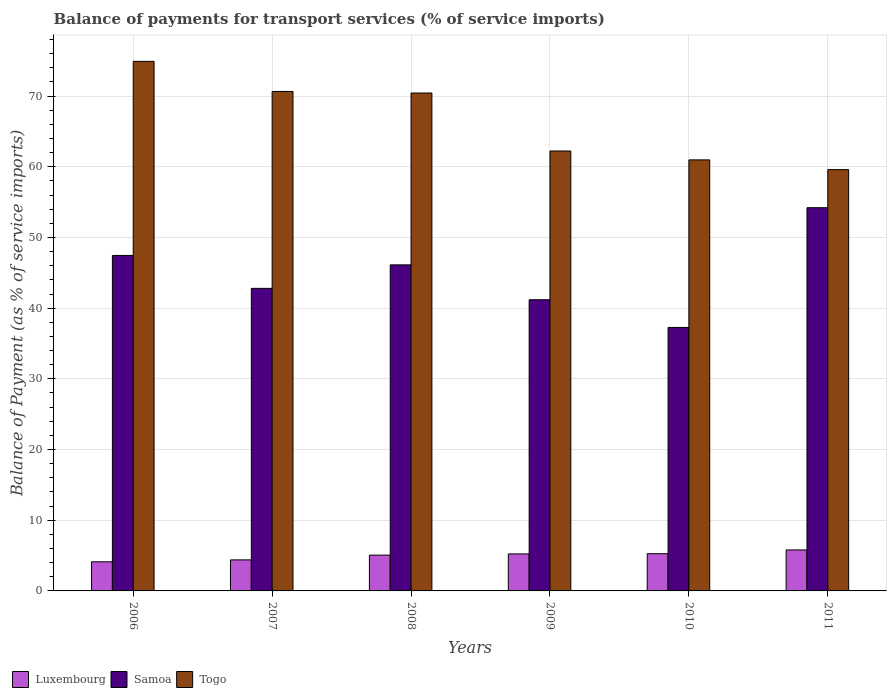How many groups of bars are there?
Provide a succinct answer. 6. Are the number of bars per tick equal to the number of legend labels?
Your answer should be very brief. Yes. How many bars are there on the 5th tick from the left?
Offer a very short reply. 3. What is the balance of payments for transport services in Luxembourg in 2008?
Keep it short and to the point. 5.07. Across all years, what is the maximum balance of payments for transport services in Samoa?
Ensure brevity in your answer.  54.21. Across all years, what is the minimum balance of payments for transport services in Luxembourg?
Give a very brief answer. 4.12. In which year was the balance of payments for transport services in Togo maximum?
Provide a succinct answer. 2006. What is the total balance of payments for transport services in Togo in the graph?
Offer a terse response. 398.79. What is the difference between the balance of payments for transport services in Luxembourg in 2007 and that in 2011?
Your answer should be compact. -1.41. What is the difference between the balance of payments for transport services in Samoa in 2009 and the balance of payments for transport services in Togo in 2006?
Your answer should be compact. -33.72. What is the average balance of payments for transport services in Togo per year?
Provide a succinct answer. 66.46. In the year 2011, what is the difference between the balance of payments for transport services in Samoa and balance of payments for transport services in Togo?
Provide a succinct answer. -5.38. In how many years, is the balance of payments for transport services in Samoa greater than 64 %?
Give a very brief answer. 0. What is the ratio of the balance of payments for transport services in Luxembourg in 2008 to that in 2010?
Offer a very short reply. 0.96. Is the balance of payments for transport services in Luxembourg in 2006 less than that in 2007?
Provide a short and direct response. Yes. Is the difference between the balance of payments for transport services in Samoa in 2008 and 2010 greater than the difference between the balance of payments for transport services in Togo in 2008 and 2010?
Give a very brief answer. No. What is the difference between the highest and the second highest balance of payments for transport services in Luxembourg?
Offer a very short reply. 0.53. What is the difference between the highest and the lowest balance of payments for transport services in Samoa?
Offer a very short reply. 16.94. What does the 3rd bar from the left in 2010 represents?
Offer a very short reply. Togo. What does the 1st bar from the right in 2011 represents?
Ensure brevity in your answer.  Togo. Is it the case that in every year, the sum of the balance of payments for transport services in Luxembourg and balance of payments for transport services in Togo is greater than the balance of payments for transport services in Samoa?
Ensure brevity in your answer.  Yes. Are all the bars in the graph horizontal?
Your response must be concise. No. What is the difference between two consecutive major ticks on the Y-axis?
Offer a terse response. 10. How many legend labels are there?
Your answer should be very brief. 3. How are the legend labels stacked?
Keep it short and to the point. Horizontal. What is the title of the graph?
Your answer should be compact. Balance of payments for transport services (% of service imports). Does "Trinidad and Tobago" appear as one of the legend labels in the graph?
Your answer should be very brief. No. What is the label or title of the X-axis?
Provide a short and direct response. Years. What is the label or title of the Y-axis?
Provide a short and direct response. Balance of Payment (as % of service imports). What is the Balance of Payment (as % of service imports) of Luxembourg in 2006?
Your response must be concise. 4.12. What is the Balance of Payment (as % of service imports) of Samoa in 2006?
Offer a very short reply. 47.45. What is the Balance of Payment (as % of service imports) in Togo in 2006?
Provide a short and direct response. 74.91. What is the Balance of Payment (as % of service imports) in Luxembourg in 2007?
Your answer should be very brief. 4.39. What is the Balance of Payment (as % of service imports) of Samoa in 2007?
Keep it short and to the point. 42.8. What is the Balance of Payment (as % of service imports) of Togo in 2007?
Your answer should be compact. 70.65. What is the Balance of Payment (as % of service imports) in Luxembourg in 2008?
Provide a short and direct response. 5.07. What is the Balance of Payment (as % of service imports) in Samoa in 2008?
Provide a succinct answer. 46.12. What is the Balance of Payment (as % of service imports) in Togo in 2008?
Make the answer very short. 70.43. What is the Balance of Payment (as % of service imports) in Luxembourg in 2009?
Your answer should be compact. 5.23. What is the Balance of Payment (as % of service imports) in Samoa in 2009?
Offer a terse response. 41.19. What is the Balance of Payment (as % of service imports) in Togo in 2009?
Make the answer very short. 62.23. What is the Balance of Payment (as % of service imports) in Luxembourg in 2010?
Your answer should be compact. 5.27. What is the Balance of Payment (as % of service imports) of Samoa in 2010?
Give a very brief answer. 37.27. What is the Balance of Payment (as % of service imports) of Togo in 2010?
Offer a terse response. 60.97. What is the Balance of Payment (as % of service imports) of Luxembourg in 2011?
Offer a terse response. 5.8. What is the Balance of Payment (as % of service imports) of Samoa in 2011?
Keep it short and to the point. 54.21. What is the Balance of Payment (as % of service imports) of Togo in 2011?
Offer a very short reply. 59.59. Across all years, what is the maximum Balance of Payment (as % of service imports) of Luxembourg?
Offer a very short reply. 5.8. Across all years, what is the maximum Balance of Payment (as % of service imports) in Samoa?
Make the answer very short. 54.21. Across all years, what is the maximum Balance of Payment (as % of service imports) of Togo?
Your answer should be very brief. 74.91. Across all years, what is the minimum Balance of Payment (as % of service imports) of Luxembourg?
Offer a very short reply. 4.12. Across all years, what is the minimum Balance of Payment (as % of service imports) in Samoa?
Keep it short and to the point. 37.27. Across all years, what is the minimum Balance of Payment (as % of service imports) in Togo?
Keep it short and to the point. 59.59. What is the total Balance of Payment (as % of service imports) of Luxembourg in the graph?
Provide a short and direct response. 29.88. What is the total Balance of Payment (as % of service imports) in Samoa in the graph?
Your response must be concise. 269.04. What is the total Balance of Payment (as % of service imports) in Togo in the graph?
Your answer should be compact. 398.79. What is the difference between the Balance of Payment (as % of service imports) of Luxembourg in 2006 and that in 2007?
Provide a succinct answer. -0.27. What is the difference between the Balance of Payment (as % of service imports) of Samoa in 2006 and that in 2007?
Your answer should be compact. 4.66. What is the difference between the Balance of Payment (as % of service imports) of Togo in 2006 and that in 2007?
Provide a succinct answer. 4.26. What is the difference between the Balance of Payment (as % of service imports) in Luxembourg in 2006 and that in 2008?
Ensure brevity in your answer.  -0.94. What is the difference between the Balance of Payment (as % of service imports) of Samoa in 2006 and that in 2008?
Offer a very short reply. 1.33. What is the difference between the Balance of Payment (as % of service imports) in Togo in 2006 and that in 2008?
Your answer should be very brief. 4.48. What is the difference between the Balance of Payment (as % of service imports) of Luxembourg in 2006 and that in 2009?
Your answer should be compact. -1.11. What is the difference between the Balance of Payment (as % of service imports) of Samoa in 2006 and that in 2009?
Offer a very short reply. 6.27. What is the difference between the Balance of Payment (as % of service imports) in Togo in 2006 and that in 2009?
Offer a terse response. 12.68. What is the difference between the Balance of Payment (as % of service imports) of Luxembourg in 2006 and that in 2010?
Give a very brief answer. -1.14. What is the difference between the Balance of Payment (as % of service imports) in Samoa in 2006 and that in 2010?
Your answer should be very brief. 10.18. What is the difference between the Balance of Payment (as % of service imports) in Togo in 2006 and that in 2010?
Keep it short and to the point. 13.94. What is the difference between the Balance of Payment (as % of service imports) of Luxembourg in 2006 and that in 2011?
Your answer should be very brief. -1.68. What is the difference between the Balance of Payment (as % of service imports) in Samoa in 2006 and that in 2011?
Offer a terse response. -6.76. What is the difference between the Balance of Payment (as % of service imports) of Togo in 2006 and that in 2011?
Make the answer very short. 15.32. What is the difference between the Balance of Payment (as % of service imports) in Luxembourg in 2007 and that in 2008?
Provide a short and direct response. -0.67. What is the difference between the Balance of Payment (as % of service imports) of Samoa in 2007 and that in 2008?
Your response must be concise. -3.33. What is the difference between the Balance of Payment (as % of service imports) in Togo in 2007 and that in 2008?
Offer a very short reply. 0.22. What is the difference between the Balance of Payment (as % of service imports) of Luxembourg in 2007 and that in 2009?
Keep it short and to the point. -0.84. What is the difference between the Balance of Payment (as % of service imports) in Samoa in 2007 and that in 2009?
Provide a succinct answer. 1.61. What is the difference between the Balance of Payment (as % of service imports) in Togo in 2007 and that in 2009?
Offer a terse response. 8.42. What is the difference between the Balance of Payment (as % of service imports) of Luxembourg in 2007 and that in 2010?
Ensure brevity in your answer.  -0.87. What is the difference between the Balance of Payment (as % of service imports) of Samoa in 2007 and that in 2010?
Offer a very short reply. 5.53. What is the difference between the Balance of Payment (as % of service imports) in Togo in 2007 and that in 2010?
Your answer should be very brief. 9.68. What is the difference between the Balance of Payment (as % of service imports) in Luxembourg in 2007 and that in 2011?
Keep it short and to the point. -1.41. What is the difference between the Balance of Payment (as % of service imports) in Samoa in 2007 and that in 2011?
Provide a short and direct response. -11.41. What is the difference between the Balance of Payment (as % of service imports) of Togo in 2007 and that in 2011?
Provide a short and direct response. 11.06. What is the difference between the Balance of Payment (as % of service imports) in Luxembourg in 2008 and that in 2009?
Provide a short and direct response. -0.17. What is the difference between the Balance of Payment (as % of service imports) of Samoa in 2008 and that in 2009?
Your response must be concise. 4.93. What is the difference between the Balance of Payment (as % of service imports) of Togo in 2008 and that in 2009?
Provide a short and direct response. 8.2. What is the difference between the Balance of Payment (as % of service imports) of Luxembourg in 2008 and that in 2010?
Your answer should be very brief. -0.2. What is the difference between the Balance of Payment (as % of service imports) of Samoa in 2008 and that in 2010?
Provide a short and direct response. 8.85. What is the difference between the Balance of Payment (as % of service imports) in Togo in 2008 and that in 2010?
Make the answer very short. 9.46. What is the difference between the Balance of Payment (as % of service imports) in Luxembourg in 2008 and that in 2011?
Your answer should be compact. -0.73. What is the difference between the Balance of Payment (as % of service imports) of Samoa in 2008 and that in 2011?
Give a very brief answer. -8.09. What is the difference between the Balance of Payment (as % of service imports) in Togo in 2008 and that in 2011?
Keep it short and to the point. 10.84. What is the difference between the Balance of Payment (as % of service imports) of Luxembourg in 2009 and that in 2010?
Give a very brief answer. -0.03. What is the difference between the Balance of Payment (as % of service imports) in Samoa in 2009 and that in 2010?
Offer a very short reply. 3.92. What is the difference between the Balance of Payment (as % of service imports) in Togo in 2009 and that in 2010?
Ensure brevity in your answer.  1.26. What is the difference between the Balance of Payment (as % of service imports) of Luxembourg in 2009 and that in 2011?
Provide a short and direct response. -0.56. What is the difference between the Balance of Payment (as % of service imports) in Samoa in 2009 and that in 2011?
Keep it short and to the point. -13.02. What is the difference between the Balance of Payment (as % of service imports) in Togo in 2009 and that in 2011?
Offer a very short reply. 2.64. What is the difference between the Balance of Payment (as % of service imports) of Luxembourg in 2010 and that in 2011?
Give a very brief answer. -0.53. What is the difference between the Balance of Payment (as % of service imports) in Samoa in 2010 and that in 2011?
Offer a terse response. -16.94. What is the difference between the Balance of Payment (as % of service imports) in Togo in 2010 and that in 2011?
Your answer should be compact. 1.38. What is the difference between the Balance of Payment (as % of service imports) in Luxembourg in 2006 and the Balance of Payment (as % of service imports) in Samoa in 2007?
Offer a terse response. -38.67. What is the difference between the Balance of Payment (as % of service imports) in Luxembourg in 2006 and the Balance of Payment (as % of service imports) in Togo in 2007?
Provide a succinct answer. -66.53. What is the difference between the Balance of Payment (as % of service imports) of Samoa in 2006 and the Balance of Payment (as % of service imports) of Togo in 2007?
Make the answer very short. -23.2. What is the difference between the Balance of Payment (as % of service imports) of Luxembourg in 2006 and the Balance of Payment (as % of service imports) of Samoa in 2008?
Your response must be concise. -42. What is the difference between the Balance of Payment (as % of service imports) of Luxembourg in 2006 and the Balance of Payment (as % of service imports) of Togo in 2008?
Give a very brief answer. -66.31. What is the difference between the Balance of Payment (as % of service imports) in Samoa in 2006 and the Balance of Payment (as % of service imports) in Togo in 2008?
Make the answer very short. -22.98. What is the difference between the Balance of Payment (as % of service imports) in Luxembourg in 2006 and the Balance of Payment (as % of service imports) in Samoa in 2009?
Provide a succinct answer. -37.07. What is the difference between the Balance of Payment (as % of service imports) of Luxembourg in 2006 and the Balance of Payment (as % of service imports) of Togo in 2009?
Provide a short and direct response. -58.11. What is the difference between the Balance of Payment (as % of service imports) of Samoa in 2006 and the Balance of Payment (as % of service imports) of Togo in 2009?
Give a very brief answer. -14.77. What is the difference between the Balance of Payment (as % of service imports) of Luxembourg in 2006 and the Balance of Payment (as % of service imports) of Samoa in 2010?
Provide a short and direct response. -33.15. What is the difference between the Balance of Payment (as % of service imports) of Luxembourg in 2006 and the Balance of Payment (as % of service imports) of Togo in 2010?
Make the answer very short. -56.85. What is the difference between the Balance of Payment (as % of service imports) of Samoa in 2006 and the Balance of Payment (as % of service imports) of Togo in 2010?
Provide a short and direct response. -13.52. What is the difference between the Balance of Payment (as % of service imports) in Luxembourg in 2006 and the Balance of Payment (as % of service imports) in Samoa in 2011?
Your answer should be compact. -50.09. What is the difference between the Balance of Payment (as % of service imports) in Luxembourg in 2006 and the Balance of Payment (as % of service imports) in Togo in 2011?
Ensure brevity in your answer.  -55.47. What is the difference between the Balance of Payment (as % of service imports) in Samoa in 2006 and the Balance of Payment (as % of service imports) in Togo in 2011?
Offer a terse response. -12.14. What is the difference between the Balance of Payment (as % of service imports) in Luxembourg in 2007 and the Balance of Payment (as % of service imports) in Samoa in 2008?
Your answer should be very brief. -41.73. What is the difference between the Balance of Payment (as % of service imports) in Luxembourg in 2007 and the Balance of Payment (as % of service imports) in Togo in 2008?
Offer a very short reply. -66.04. What is the difference between the Balance of Payment (as % of service imports) in Samoa in 2007 and the Balance of Payment (as % of service imports) in Togo in 2008?
Keep it short and to the point. -27.63. What is the difference between the Balance of Payment (as % of service imports) of Luxembourg in 2007 and the Balance of Payment (as % of service imports) of Samoa in 2009?
Your response must be concise. -36.8. What is the difference between the Balance of Payment (as % of service imports) of Luxembourg in 2007 and the Balance of Payment (as % of service imports) of Togo in 2009?
Give a very brief answer. -57.84. What is the difference between the Balance of Payment (as % of service imports) of Samoa in 2007 and the Balance of Payment (as % of service imports) of Togo in 2009?
Make the answer very short. -19.43. What is the difference between the Balance of Payment (as % of service imports) in Luxembourg in 2007 and the Balance of Payment (as % of service imports) in Samoa in 2010?
Give a very brief answer. -32.88. What is the difference between the Balance of Payment (as % of service imports) of Luxembourg in 2007 and the Balance of Payment (as % of service imports) of Togo in 2010?
Ensure brevity in your answer.  -56.58. What is the difference between the Balance of Payment (as % of service imports) of Samoa in 2007 and the Balance of Payment (as % of service imports) of Togo in 2010?
Make the answer very short. -18.18. What is the difference between the Balance of Payment (as % of service imports) in Luxembourg in 2007 and the Balance of Payment (as % of service imports) in Samoa in 2011?
Offer a terse response. -49.82. What is the difference between the Balance of Payment (as % of service imports) of Luxembourg in 2007 and the Balance of Payment (as % of service imports) of Togo in 2011?
Offer a terse response. -55.2. What is the difference between the Balance of Payment (as % of service imports) of Samoa in 2007 and the Balance of Payment (as % of service imports) of Togo in 2011?
Keep it short and to the point. -16.8. What is the difference between the Balance of Payment (as % of service imports) of Luxembourg in 2008 and the Balance of Payment (as % of service imports) of Samoa in 2009?
Offer a terse response. -36.12. What is the difference between the Balance of Payment (as % of service imports) of Luxembourg in 2008 and the Balance of Payment (as % of service imports) of Togo in 2009?
Provide a short and direct response. -57.16. What is the difference between the Balance of Payment (as % of service imports) of Samoa in 2008 and the Balance of Payment (as % of service imports) of Togo in 2009?
Give a very brief answer. -16.11. What is the difference between the Balance of Payment (as % of service imports) of Luxembourg in 2008 and the Balance of Payment (as % of service imports) of Samoa in 2010?
Provide a succinct answer. -32.21. What is the difference between the Balance of Payment (as % of service imports) in Luxembourg in 2008 and the Balance of Payment (as % of service imports) in Togo in 2010?
Provide a short and direct response. -55.91. What is the difference between the Balance of Payment (as % of service imports) of Samoa in 2008 and the Balance of Payment (as % of service imports) of Togo in 2010?
Keep it short and to the point. -14.85. What is the difference between the Balance of Payment (as % of service imports) of Luxembourg in 2008 and the Balance of Payment (as % of service imports) of Samoa in 2011?
Offer a very short reply. -49.15. What is the difference between the Balance of Payment (as % of service imports) in Luxembourg in 2008 and the Balance of Payment (as % of service imports) in Togo in 2011?
Keep it short and to the point. -54.53. What is the difference between the Balance of Payment (as % of service imports) in Samoa in 2008 and the Balance of Payment (as % of service imports) in Togo in 2011?
Provide a short and direct response. -13.47. What is the difference between the Balance of Payment (as % of service imports) in Luxembourg in 2009 and the Balance of Payment (as % of service imports) in Samoa in 2010?
Ensure brevity in your answer.  -32.04. What is the difference between the Balance of Payment (as % of service imports) in Luxembourg in 2009 and the Balance of Payment (as % of service imports) in Togo in 2010?
Offer a terse response. -55.74. What is the difference between the Balance of Payment (as % of service imports) in Samoa in 2009 and the Balance of Payment (as % of service imports) in Togo in 2010?
Your answer should be compact. -19.78. What is the difference between the Balance of Payment (as % of service imports) in Luxembourg in 2009 and the Balance of Payment (as % of service imports) in Samoa in 2011?
Provide a succinct answer. -48.98. What is the difference between the Balance of Payment (as % of service imports) in Luxembourg in 2009 and the Balance of Payment (as % of service imports) in Togo in 2011?
Your answer should be compact. -54.36. What is the difference between the Balance of Payment (as % of service imports) of Samoa in 2009 and the Balance of Payment (as % of service imports) of Togo in 2011?
Make the answer very short. -18.4. What is the difference between the Balance of Payment (as % of service imports) of Luxembourg in 2010 and the Balance of Payment (as % of service imports) of Samoa in 2011?
Your response must be concise. -48.94. What is the difference between the Balance of Payment (as % of service imports) of Luxembourg in 2010 and the Balance of Payment (as % of service imports) of Togo in 2011?
Make the answer very short. -54.33. What is the difference between the Balance of Payment (as % of service imports) in Samoa in 2010 and the Balance of Payment (as % of service imports) in Togo in 2011?
Provide a short and direct response. -22.32. What is the average Balance of Payment (as % of service imports) in Luxembourg per year?
Your answer should be compact. 4.98. What is the average Balance of Payment (as % of service imports) of Samoa per year?
Make the answer very short. 44.84. What is the average Balance of Payment (as % of service imports) in Togo per year?
Ensure brevity in your answer.  66.46. In the year 2006, what is the difference between the Balance of Payment (as % of service imports) in Luxembourg and Balance of Payment (as % of service imports) in Samoa?
Provide a short and direct response. -43.33. In the year 2006, what is the difference between the Balance of Payment (as % of service imports) of Luxembourg and Balance of Payment (as % of service imports) of Togo?
Give a very brief answer. -70.79. In the year 2006, what is the difference between the Balance of Payment (as % of service imports) in Samoa and Balance of Payment (as % of service imports) in Togo?
Provide a short and direct response. -27.45. In the year 2007, what is the difference between the Balance of Payment (as % of service imports) of Luxembourg and Balance of Payment (as % of service imports) of Samoa?
Give a very brief answer. -38.41. In the year 2007, what is the difference between the Balance of Payment (as % of service imports) in Luxembourg and Balance of Payment (as % of service imports) in Togo?
Offer a very short reply. -66.26. In the year 2007, what is the difference between the Balance of Payment (as % of service imports) in Samoa and Balance of Payment (as % of service imports) in Togo?
Make the answer very short. -27.86. In the year 2008, what is the difference between the Balance of Payment (as % of service imports) of Luxembourg and Balance of Payment (as % of service imports) of Samoa?
Make the answer very short. -41.06. In the year 2008, what is the difference between the Balance of Payment (as % of service imports) in Luxembourg and Balance of Payment (as % of service imports) in Togo?
Make the answer very short. -65.37. In the year 2008, what is the difference between the Balance of Payment (as % of service imports) in Samoa and Balance of Payment (as % of service imports) in Togo?
Give a very brief answer. -24.31. In the year 2009, what is the difference between the Balance of Payment (as % of service imports) in Luxembourg and Balance of Payment (as % of service imports) in Samoa?
Make the answer very short. -35.95. In the year 2009, what is the difference between the Balance of Payment (as % of service imports) of Luxembourg and Balance of Payment (as % of service imports) of Togo?
Your answer should be compact. -57. In the year 2009, what is the difference between the Balance of Payment (as % of service imports) of Samoa and Balance of Payment (as % of service imports) of Togo?
Ensure brevity in your answer.  -21.04. In the year 2010, what is the difference between the Balance of Payment (as % of service imports) of Luxembourg and Balance of Payment (as % of service imports) of Samoa?
Your answer should be very brief. -32. In the year 2010, what is the difference between the Balance of Payment (as % of service imports) in Luxembourg and Balance of Payment (as % of service imports) in Togo?
Provide a short and direct response. -55.71. In the year 2010, what is the difference between the Balance of Payment (as % of service imports) of Samoa and Balance of Payment (as % of service imports) of Togo?
Ensure brevity in your answer.  -23.7. In the year 2011, what is the difference between the Balance of Payment (as % of service imports) in Luxembourg and Balance of Payment (as % of service imports) in Samoa?
Provide a succinct answer. -48.41. In the year 2011, what is the difference between the Balance of Payment (as % of service imports) in Luxembourg and Balance of Payment (as % of service imports) in Togo?
Offer a very short reply. -53.79. In the year 2011, what is the difference between the Balance of Payment (as % of service imports) in Samoa and Balance of Payment (as % of service imports) in Togo?
Your answer should be compact. -5.38. What is the ratio of the Balance of Payment (as % of service imports) in Luxembourg in 2006 to that in 2007?
Your answer should be very brief. 0.94. What is the ratio of the Balance of Payment (as % of service imports) of Samoa in 2006 to that in 2007?
Your answer should be very brief. 1.11. What is the ratio of the Balance of Payment (as % of service imports) of Togo in 2006 to that in 2007?
Your answer should be compact. 1.06. What is the ratio of the Balance of Payment (as % of service imports) in Luxembourg in 2006 to that in 2008?
Keep it short and to the point. 0.81. What is the ratio of the Balance of Payment (as % of service imports) of Samoa in 2006 to that in 2008?
Offer a very short reply. 1.03. What is the ratio of the Balance of Payment (as % of service imports) of Togo in 2006 to that in 2008?
Keep it short and to the point. 1.06. What is the ratio of the Balance of Payment (as % of service imports) of Luxembourg in 2006 to that in 2009?
Give a very brief answer. 0.79. What is the ratio of the Balance of Payment (as % of service imports) in Samoa in 2006 to that in 2009?
Provide a succinct answer. 1.15. What is the ratio of the Balance of Payment (as % of service imports) of Togo in 2006 to that in 2009?
Provide a short and direct response. 1.2. What is the ratio of the Balance of Payment (as % of service imports) of Luxembourg in 2006 to that in 2010?
Make the answer very short. 0.78. What is the ratio of the Balance of Payment (as % of service imports) of Samoa in 2006 to that in 2010?
Your answer should be very brief. 1.27. What is the ratio of the Balance of Payment (as % of service imports) in Togo in 2006 to that in 2010?
Offer a very short reply. 1.23. What is the ratio of the Balance of Payment (as % of service imports) of Luxembourg in 2006 to that in 2011?
Your answer should be very brief. 0.71. What is the ratio of the Balance of Payment (as % of service imports) of Samoa in 2006 to that in 2011?
Offer a terse response. 0.88. What is the ratio of the Balance of Payment (as % of service imports) in Togo in 2006 to that in 2011?
Your response must be concise. 1.26. What is the ratio of the Balance of Payment (as % of service imports) of Luxembourg in 2007 to that in 2008?
Your answer should be compact. 0.87. What is the ratio of the Balance of Payment (as % of service imports) of Samoa in 2007 to that in 2008?
Ensure brevity in your answer.  0.93. What is the ratio of the Balance of Payment (as % of service imports) in Luxembourg in 2007 to that in 2009?
Make the answer very short. 0.84. What is the ratio of the Balance of Payment (as % of service imports) in Samoa in 2007 to that in 2009?
Provide a short and direct response. 1.04. What is the ratio of the Balance of Payment (as % of service imports) in Togo in 2007 to that in 2009?
Keep it short and to the point. 1.14. What is the ratio of the Balance of Payment (as % of service imports) of Luxembourg in 2007 to that in 2010?
Keep it short and to the point. 0.83. What is the ratio of the Balance of Payment (as % of service imports) in Samoa in 2007 to that in 2010?
Ensure brevity in your answer.  1.15. What is the ratio of the Balance of Payment (as % of service imports) of Togo in 2007 to that in 2010?
Provide a short and direct response. 1.16. What is the ratio of the Balance of Payment (as % of service imports) in Luxembourg in 2007 to that in 2011?
Your response must be concise. 0.76. What is the ratio of the Balance of Payment (as % of service imports) in Samoa in 2007 to that in 2011?
Your answer should be compact. 0.79. What is the ratio of the Balance of Payment (as % of service imports) of Togo in 2007 to that in 2011?
Provide a short and direct response. 1.19. What is the ratio of the Balance of Payment (as % of service imports) in Luxembourg in 2008 to that in 2009?
Your answer should be compact. 0.97. What is the ratio of the Balance of Payment (as % of service imports) of Samoa in 2008 to that in 2009?
Provide a short and direct response. 1.12. What is the ratio of the Balance of Payment (as % of service imports) in Togo in 2008 to that in 2009?
Ensure brevity in your answer.  1.13. What is the ratio of the Balance of Payment (as % of service imports) in Luxembourg in 2008 to that in 2010?
Provide a succinct answer. 0.96. What is the ratio of the Balance of Payment (as % of service imports) in Samoa in 2008 to that in 2010?
Ensure brevity in your answer.  1.24. What is the ratio of the Balance of Payment (as % of service imports) of Togo in 2008 to that in 2010?
Ensure brevity in your answer.  1.16. What is the ratio of the Balance of Payment (as % of service imports) of Luxembourg in 2008 to that in 2011?
Provide a short and direct response. 0.87. What is the ratio of the Balance of Payment (as % of service imports) in Samoa in 2008 to that in 2011?
Offer a terse response. 0.85. What is the ratio of the Balance of Payment (as % of service imports) in Togo in 2008 to that in 2011?
Give a very brief answer. 1.18. What is the ratio of the Balance of Payment (as % of service imports) in Luxembourg in 2009 to that in 2010?
Keep it short and to the point. 0.99. What is the ratio of the Balance of Payment (as % of service imports) in Samoa in 2009 to that in 2010?
Your response must be concise. 1.11. What is the ratio of the Balance of Payment (as % of service imports) of Togo in 2009 to that in 2010?
Your response must be concise. 1.02. What is the ratio of the Balance of Payment (as % of service imports) of Luxembourg in 2009 to that in 2011?
Ensure brevity in your answer.  0.9. What is the ratio of the Balance of Payment (as % of service imports) in Samoa in 2009 to that in 2011?
Offer a terse response. 0.76. What is the ratio of the Balance of Payment (as % of service imports) of Togo in 2009 to that in 2011?
Your response must be concise. 1.04. What is the ratio of the Balance of Payment (as % of service imports) of Luxembourg in 2010 to that in 2011?
Make the answer very short. 0.91. What is the ratio of the Balance of Payment (as % of service imports) in Samoa in 2010 to that in 2011?
Ensure brevity in your answer.  0.69. What is the ratio of the Balance of Payment (as % of service imports) in Togo in 2010 to that in 2011?
Offer a very short reply. 1.02. What is the difference between the highest and the second highest Balance of Payment (as % of service imports) in Luxembourg?
Your answer should be compact. 0.53. What is the difference between the highest and the second highest Balance of Payment (as % of service imports) in Samoa?
Provide a short and direct response. 6.76. What is the difference between the highest and the second highest Balance of Payment (as % of service imports) in Togo?
Offer a terse response. 4.26. What is the difference between the highest and the lowest Balance of Payment (as % of service imports) in Luxembourg?
Your response must be concise. 1.68. What is the difference between the highest and the lowest Balance of Payment (as % of service imports) of Samoa?
Make the answer very short. 16.94. What is the difference between the highest and the lowest Balance of Payment (as % of service imports) of Togo?
Your response must be concise. 15.32. 